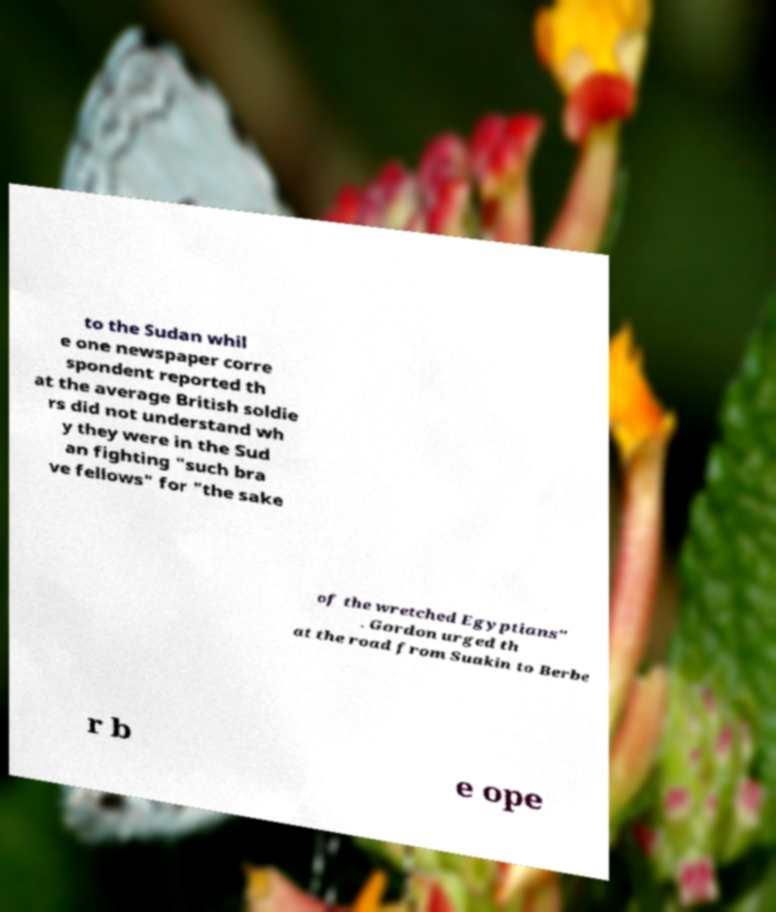Could you assist in decoding the text presented in this image and type it out clearly? to the Sudan whil e one newspaper corre spondent reported th at the average British soldie rs did not understand wh y they were in the Sud an fighting "such bra ve fellows" for "the sake of the wretched Egyptians" . Gordon urged th at the road from Suakin to Berbe r b e ope 